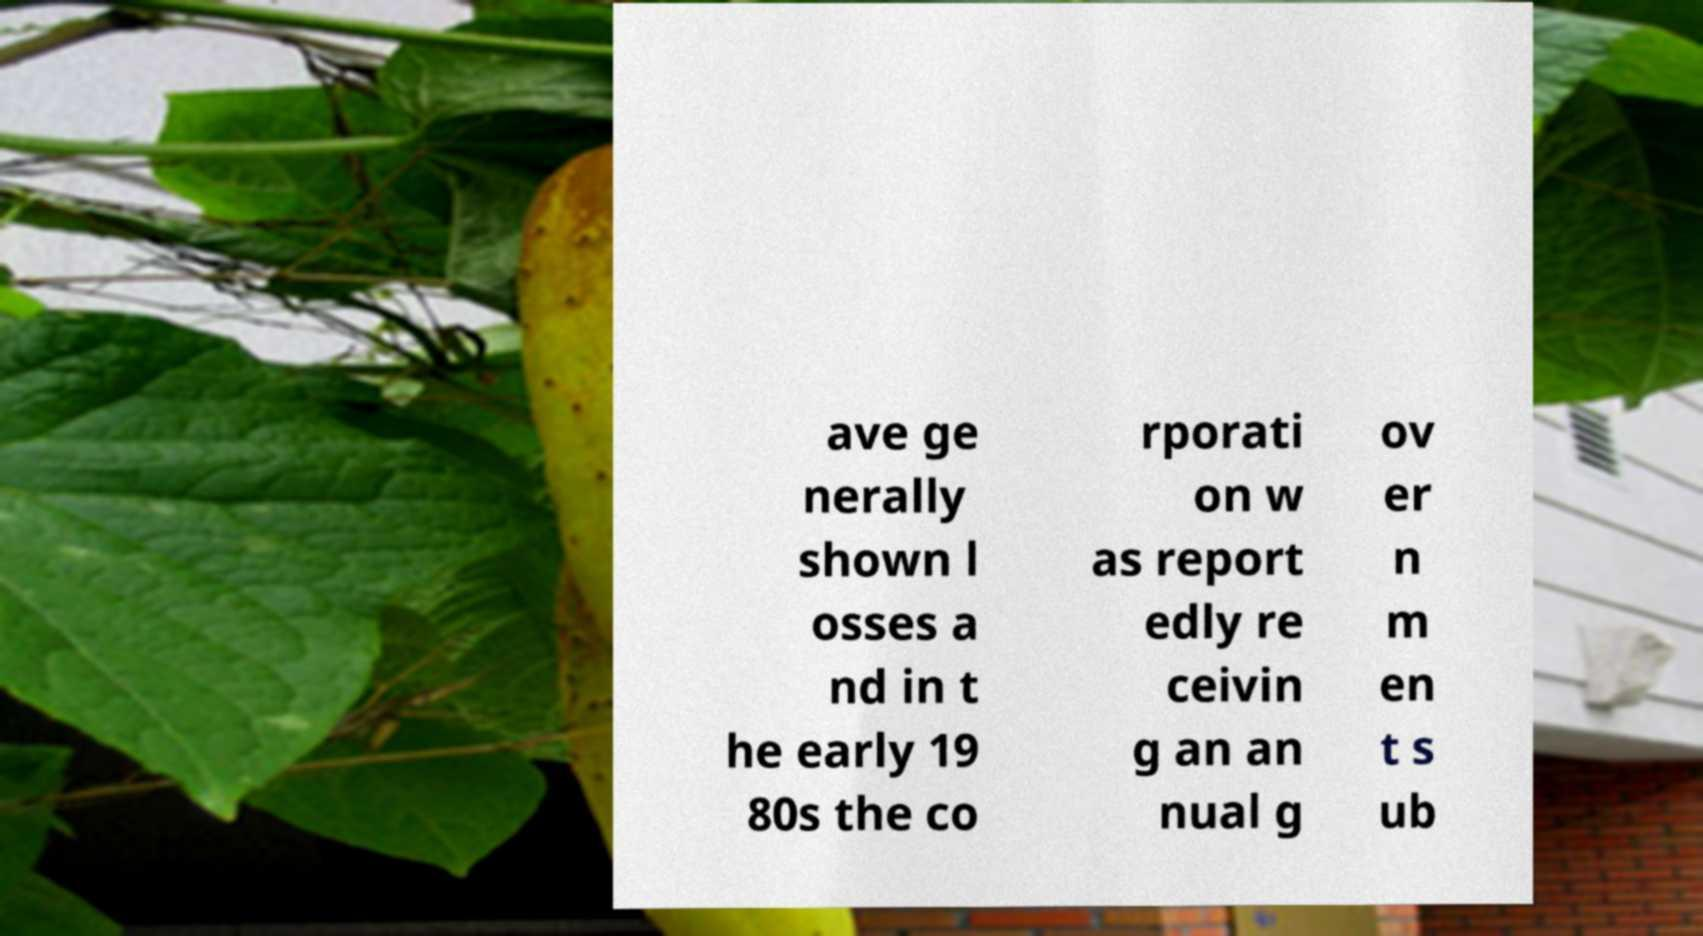Could you extract and type out the text from this image? ave ge nerally shown l osses a nd in t he early 19 80s the co rporati on w as report edly re ceivin g an an nual g ov er n m en t s ub 